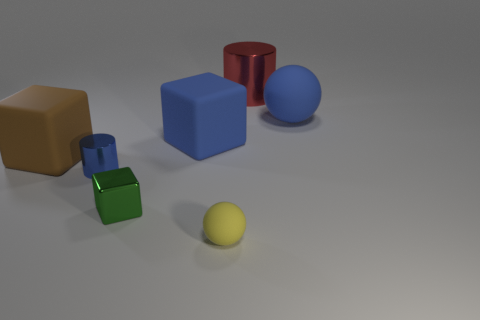Add 1 purple balls. How many objects exist? 8 Subtract all cylinders. How many objects are left? 5 Add 7 small cubes. How many small cubes exist? 8 Subtract 1 blue balls. How many objects are left? 6 Subtract all green things. Subtract all blue objects. How many objects are left? 3 Add 5 large blocks. How many large blocks are left? 7 